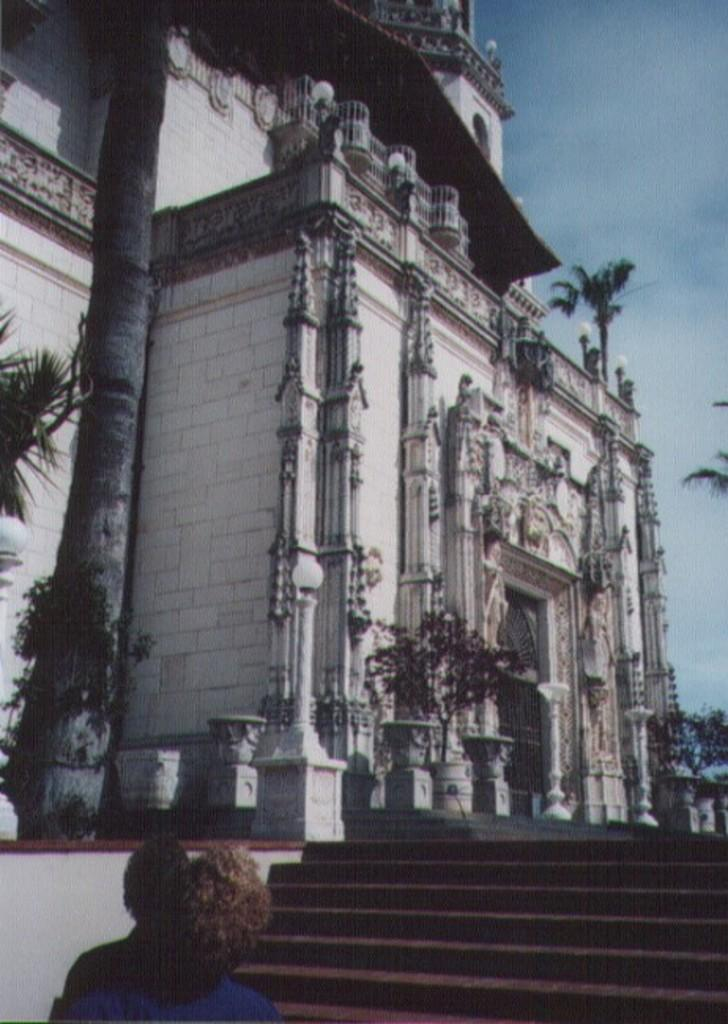What type of structure can be seen in the image? There are stairs in the image. What color are the plants in the image? The plants are green in color. What is the color of the building in the image? The building is white in color. What colors can be seen in the sky at the top of the image? The sky is blue and white in color. Where is the cub located in the image? There is no cub present in the image. What type of yam is being used as a decoration in the image? There is no yam present in the image. 